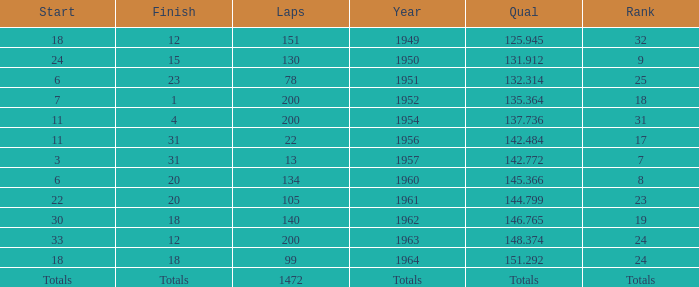Name the rank for 151 Laps 32.0. 